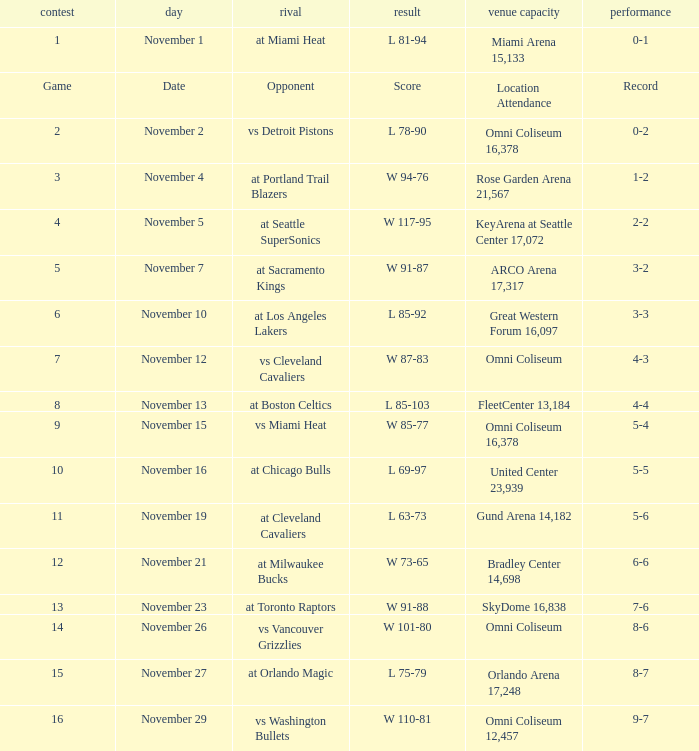Who was their opponent in game 4? At seattle supersonics. 